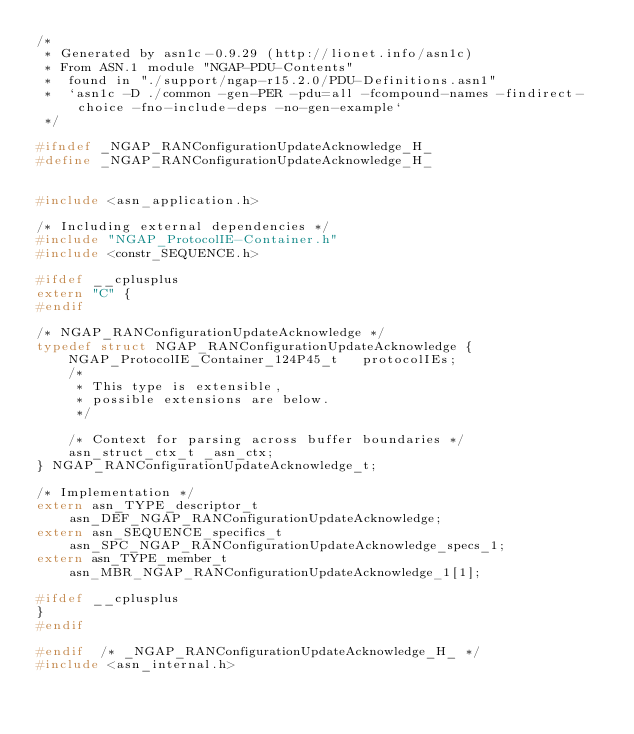<code> <loc_0><loc_0><loc_500><loc_500><_C_>/*
 * Generated by asn1c-0.9.29 (http://lionet.info/asn1c)
 * From ASN.1 module "NGAP-PDU-Contents"
 * 	found in "./support/ngap-r15.2.0/PDU-Definitions.asn1"
 * 	`asn1c -D ./common -gen-PER -pdu=all -fcompound-names -findirect-choice -fno-include-deps -no-gen-example`
 */

#ifndef	_NGAP_RANConfigurationUpdateAcknowledge_H_
#define	_NGAP_RANConfigurationUpdateAcknowledge_H_


#include <asn_application.h>

/* Including external dependencies */
#include "NGAP_ProtocolIE-Container.h"
#include <constr_SEQUENCE.h>

#ifdef __cplusplus
extern "C" {
#endif

/* NGAP_RANConfigurationUpdateAcknowledge */
typedef struct NGAP_RANConfigurationUpdateAcknowledge {
	NGAP_ProtocolIE_Container_124P45_t	 protocolIEs;
	/*
	 * This type is extensible,
	 * possible extensions are below.
	 */
	
	/* Context for parsing across buffer boundaries */
	asn_struct_ctx_t _asn_ctx;
} NGAP_RANConfigurationUpdateAcknowledge_t;

/* Implementation */
extern asn_TYPE_descriptor_t asn_DEF_NGAP_RANConfigurationUpdateAcknowledge;
extern asn_SEQUENCE_specifics_t asn_SPC_NGAP_RANConfigurationUpdateAcknowledge_specs_1;
extern asn_TYPE_member_t asn_MBR_NGAP_RANConfigurationUpdateAcknowledge_1[1];

#ifdef __cplusplus
}
#endif

#endif	/* _NGAP_RANConfigurationUpdateAcknowledge_H_ */
#include <asn_internal.h>
</code> 